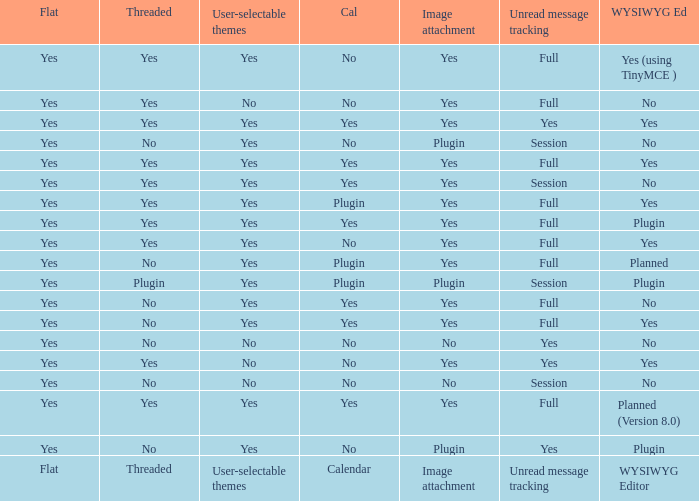Could you help me parse every detail presented in this table? {'header': ['Flat', 'Threaded', 'User-selectable themes', 'Cal', 'Image attachment', 'Unread message tracking', 'WYSIWYG Ed'], 'rows': [['Yes', 'Yes', 'Yes', 'No', 'Yes', 'Full', 'Yes (using TinyMCE )'], ['Yes', 'Yes', 'No', 'No', 'Yes', 'Full', 'No'], ['Yes', 'Yes', 'Yes', 'Yes', 'Yes', 'Yes', 'Yes'], ['Yes', 'No', 'Yes', 'No', 'Plugin', 'Session', 'No'], ['Yes', 'Yes', 'Yes', 'Yes', 'Yes', 'Full', 'Yes'], ['Yes', 'Yes', 'Yes', 'Yes', 'Yes', 'Session', 'No'], ['Yes', 'Yes', 'Yes', 'Plugin', 'Yes', 'Full', 'Yes'], ['Yes', 'Yes', 'Yes', 'Yes', 'Yes', 'Full', 'Plugin'], ['Yes', 'Yes', 'Yes', 'No', 'Yes', 'Full', 'Yes'], ['Yes', 'No', 'Yes', 'Plugin', 'Yes', 'Full', 'Planned'], ['Yes', 'Plugin', 'Yes', 'Plugin', 'Plugin', 'Session', 'Plugin'], ['Yes', 'No', 'Yes', 'Yes', 'Yes', 'Full', 'No'], ['Yes', 'No', 'Yes', 'Yes', 'Yes', 'Full', 'Yes'], ['Yes', 'No', 'No', 'No', 'No', 'Yes', 'No'], ['Yes', 'Yes', 'No', 'No', 'Yes', 'Yes', 'Yes'], ['Yes', 'No', 'No', 'No', 'No', 'Session', 'No'], ['Yes', 'Yes', 'Yes', 'Yes', 'Yes', 'Full', 'Planned (Version 8.0)'], ['Yes', 'No', 'Yes', 'No', 'Plugin', 'Yes', 'Plugin'], ['Flat', 'Threaded', 'User-selectable themes', 'Calendar', 'Image attachment', 'Unread message tracking', 'WYSIWYG Editor']]} Which Image attachment has a Threaded of yes, and a Calendar of yes? Yes, Yes, Yes, Yes, Yes. 